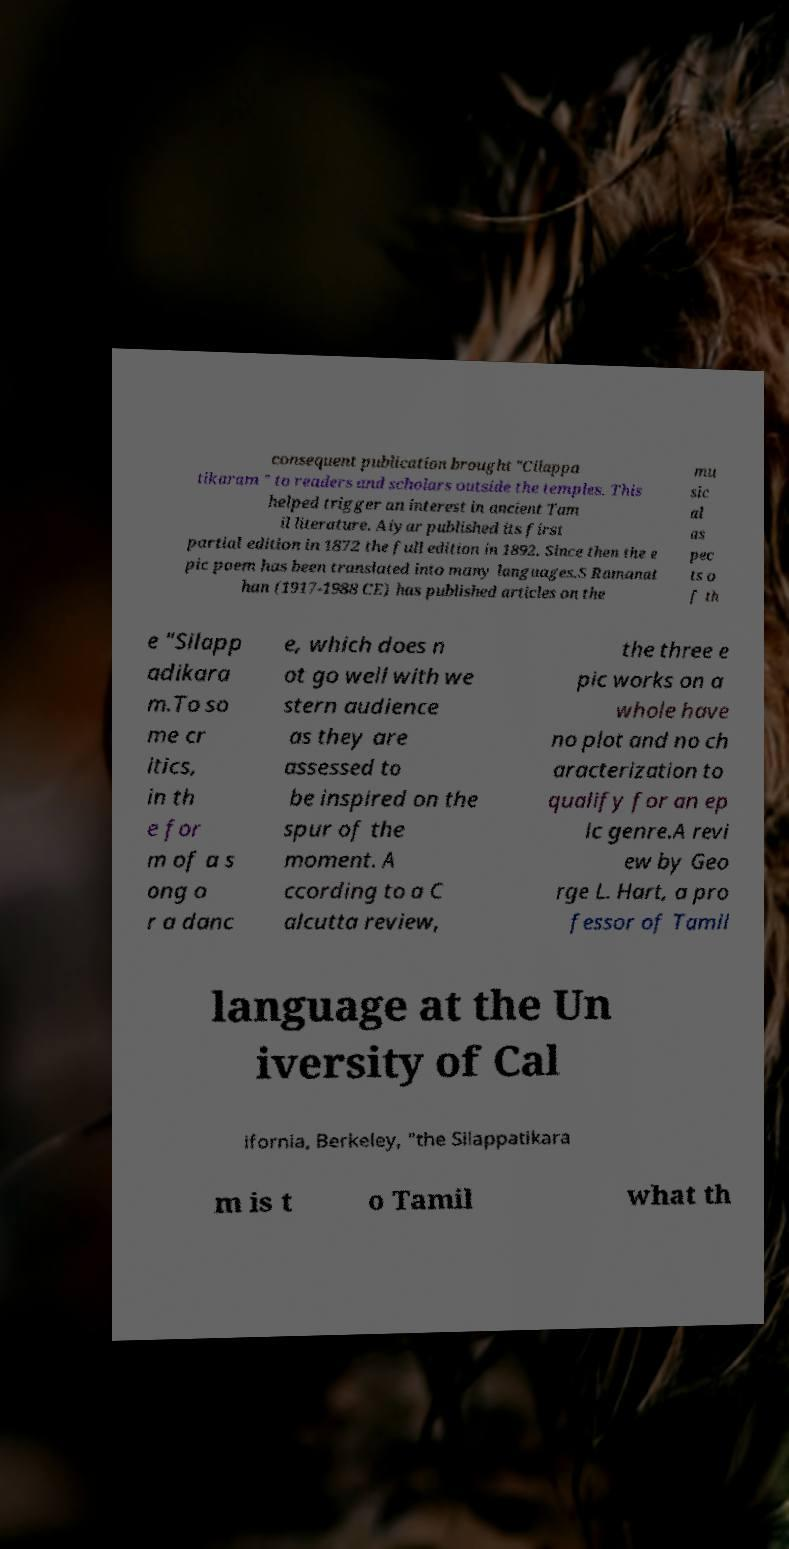Can you accurately transcribe the text from the provided image for me? consequent publication brought "Cilappa tikaram " to readers and scholars outside the temples. This helped trigger an interest in ancient Tam il literature. Aiyar published its first partial edition in 1872 the full edition in 1892. Since then the e pic poem has been translated into many languages.S Ramanat han (1917-1988 CE) has published articles on the mu sic al as pec ts o f th e "Silapp adikara m.To so me cr itics, in th e for m of a s ong o r a danc e, which does n ot go well with we stern audience as they are assessed to be inspired on the spur of the moment. A ccording to a C alcutta review, the three e pic works on a whole have no plot and no ch aracterization to qualify for an ep ic genre.A revi ew by Geo rge L. Hart, a pro fessor of Tamil language at the Un iversity of Cal ifornia, Berkeley, "the Silappatikara m is t o Tamil what th 